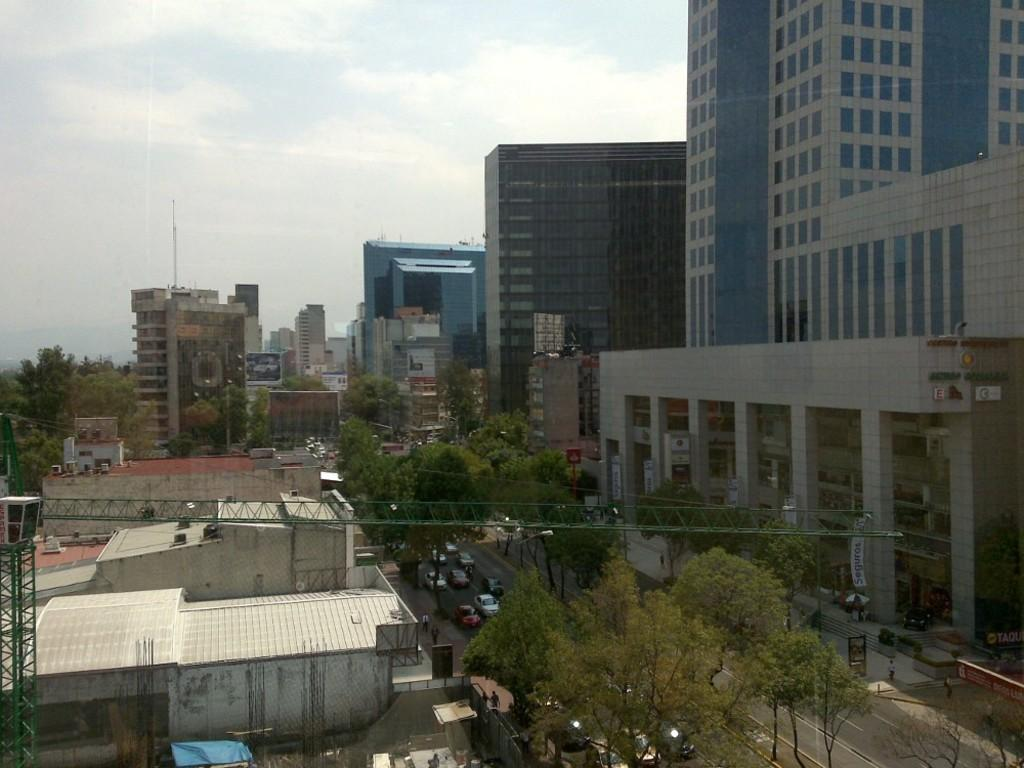What type of structures can be seen in the image? There are buildings in the image. What else can be seen in the image besides buildings? There are poles, trees, vehicles on the road, hoardings, persons on the road, windows, and clouds in the sky in the image. What type of test can be seen being conducted in the image? There is no test being conducted in the image; it features buildings, poles, trees, vehicles, hoardings, persons, windows, and clouds. 